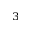<formula> <loc_0><loc_0><loc_500><loc_500>^ { 3 }</formula> 